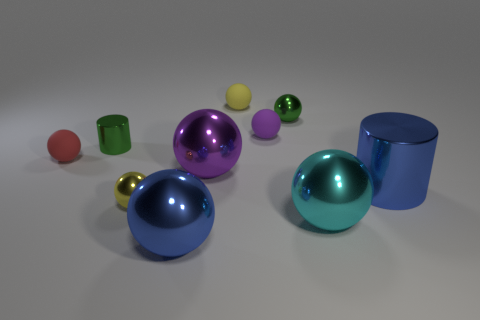Subtract all yellow spheres. How many spheres are left? 6 Subtract all red matte balls. How many balls are left? 7 Subtract all blue spheres. Subtract all yellow cylinders. How many spheres are left? 7 Subtract all cylinders. How many objects are left? 8 Add 3 tiny blue metallic things. How many tiny blue metallic things exist? 3 Subtract 0 yellow cubes. How many objects are left? 10 Subtract all large purple balls. Subtract all tiny green rubber cylinders. How many objects are left? 9 Add 9 small purple spheres. How many small purple spheres are left? 10 